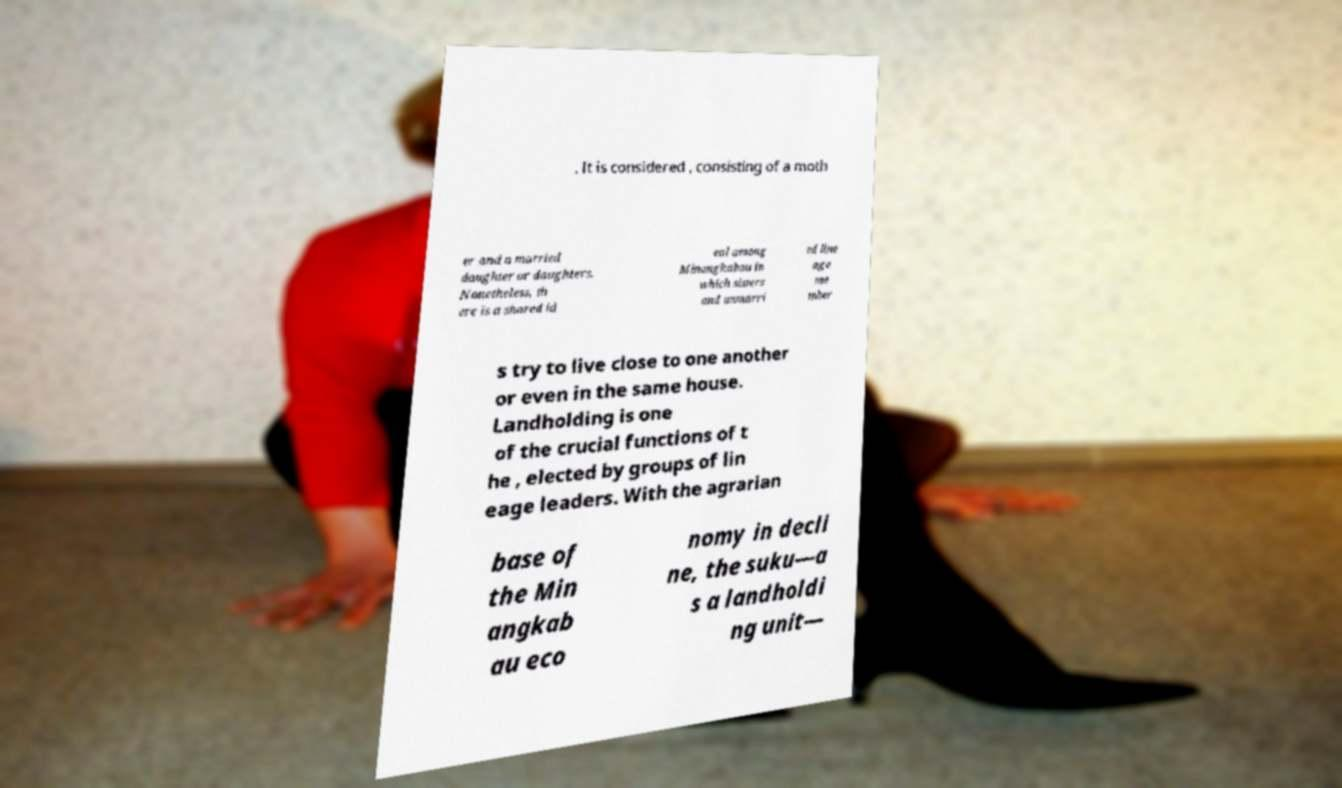Please identify and transcribe the text found in this image. . It is considered , consisting of a moth er and a married daughter or daughters. Nonetheless, th ere is a shared id eal among Minangkabau in which sisters and unmarri ed line age me mber s try to live close to one another or even in the same house. Landholding is one of the crucial functions of t he , elected by groups of lin eage leaders. With the agrarian base of the Min angkab au eco nomy in decli ne, the suku—a s a landholdi ng unit— 